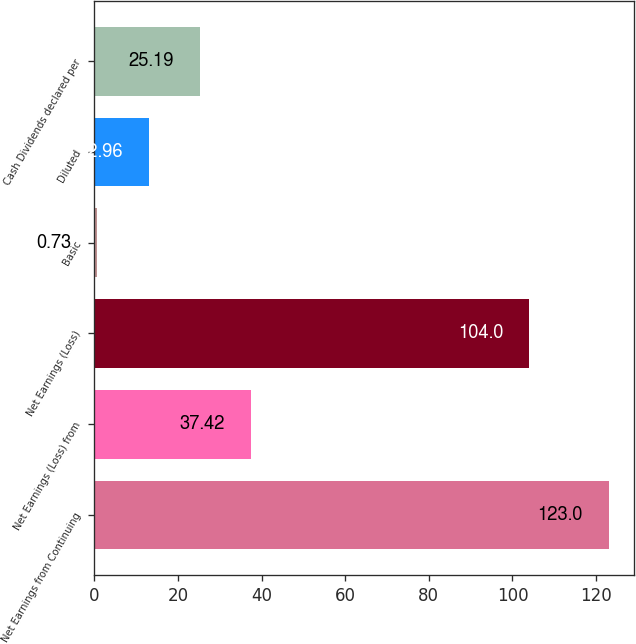<chart> <loc_0><loc_0><loc_500><loc_500><bar_chart><fcel>Net Earnings from Continuing<fcel>Net Earnings (Loss) from<fcel>Net Earnings (Loss)<fcel>Basic<fcel>Diluted<fcel>Cash Dividends declared per<nl><fcel>123<fcel>37.42<fcel>104<fcel>0.73<fcel>12.96<fcel>25.19<nl></chart> 